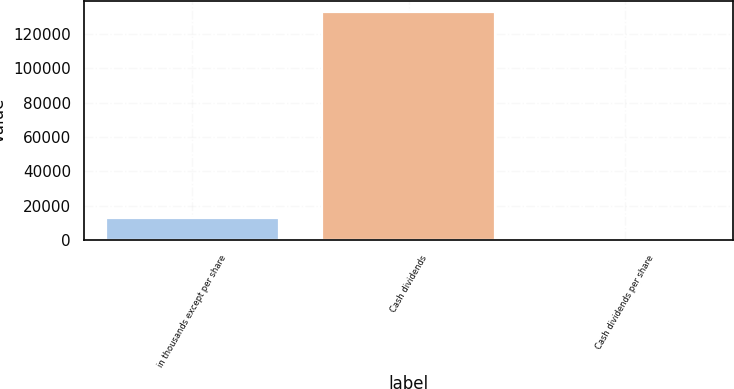Convert chart to OTSL. <chart><loc_0><loc_0><loc_500><loc_500><bar_chart><fcel>in thousands except per share<fcel>Cash dividends<fcel>Cash dividends per share<nl><fcel>13234.4<fcel>132335<fcel>1<nl></chart> 